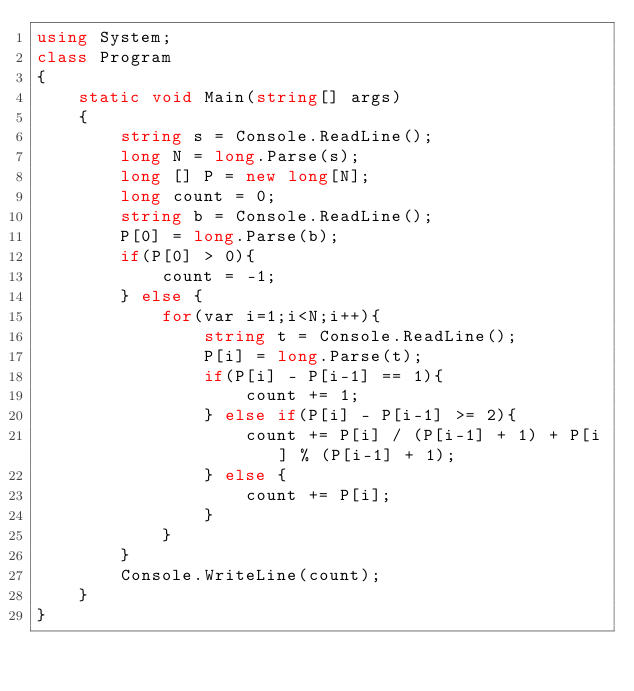<code> <loc_0><loc_0><loc_500><loc_500><_C#_>using System;
class Program
{
	static void Main(string[] args)
	{
		string s = Console.ReadLine();
		long N = long.Parse(s);
		long [] P = new long[N];
		long count = 0;
		string b = Console.ReadLine();
		P[0] = long.Parse(b);
		if(P[0] > 0){
			count = -1;
		} else {
			for(var i=1;i<N;i++){
				string t = Console.ReadLine();
				P[i] = long.Parse(t);
				if(P[i] - P[i-1] == 1){
					count += 1;
				} else if(P[i] - P[i-1] >= 2){
					count += P[i] / (P[i-1] + 1) + P[i] % (P[i-1] + 1);
				} else {
					count += P[i];
				}
			}
		}
		Console.WriteLine(count);
	}
}</code> 